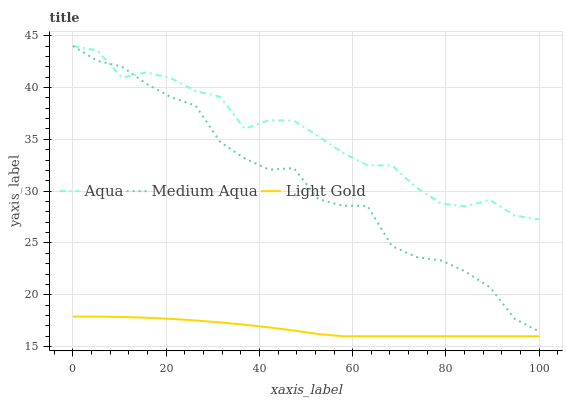Does Light Gold have the minimum area under the curve?
Answer yes or no. Yes. Does Aqua have the maximum area under the curve?
Answer yes or no. Yes. Does Aqua have the minimum area under the curve?
Answer yes or no. No. Does Light Gold have the maximum area under the curve?
Answer yes or no. No. Is Light Gold the smoothest?
Answer yes or no. Yes. Is Medium Aqua the roughest?
Answer yes or no. Yes. Is Aqua the smoothest?
Answer yes or no. No. Is Aqua the roughest?
Answer yes or no. No. Does Light Gold have the lowest value?
Answer yes or no. Yes. Does Aqua have the lowest value?
Answer yes or no. No. Does Aqua have the highest value?
Answer yes or no. Yes. Does Light Gold have the highest value?
Answer yes or no. No. Is Light Gold less than Medium Aqua?
Answer yes or no. Yes. Is Aqua greater than Light Gold?
Answer yes or no. Yes. Does Aqua intersect Medium Aqua?
Answer yes or no. Yes. Is Aqua less than Medium Aqua?
Answer yes or no. No. Is Aqua greater than Medium Aqua?
Answer yes or no. No. Does Light Gold intersect Medium Aqua?
Answer yes or no. No. 